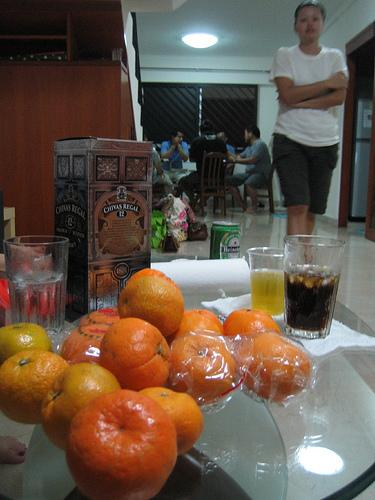The woman is doing what? Please explain your reasoning. crossing arms. A woman is standing near a table with her arms folded across the front of her body. 